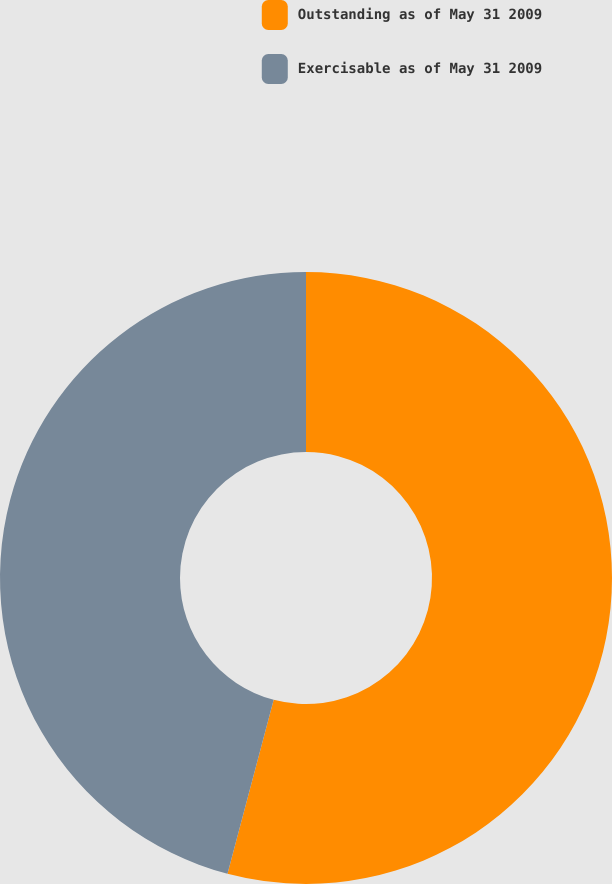Convert chart to OTSL. <chart><loc_0><loc_0><loc_500><loc_500><pie_chart><fcel>Outstanding as of May 31 2009<fcel>Exercisable as of May 31 2009<nl><fcel>54.13%<fcel>45.87%<nl></chart> 